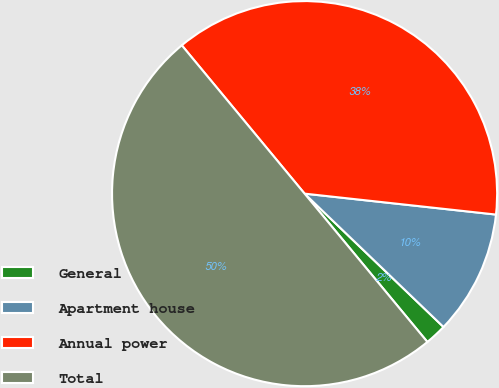<chart> <loc_0><loc_0><loc_500><loc_500><pie_chart><fcel>General<fcel>Apartment house<fcel>Annual power<fcel>Total<nl><fcel>1.82%<fcel>10.44%<fcel>37.74%<fcel>50.0%<nl></chart> 